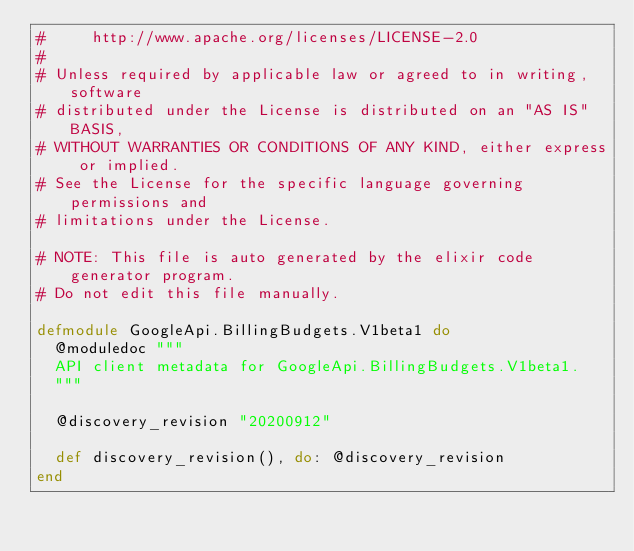<code> <loc_0><loc_0><loc_500><loc_500><_Elixir_>#     http://www.apache.org/licenses/LICENSE-2.0
#
# Unless required by applicable law or agreed to in writing, software
# distributed under the License is distributed on an "AS IS" BASIS,
# WITHOUT WARRANTIES OR CONDITIONS OF ANY KIND, either express or implied.
# See the License for the specific language governing permissions and
# limitations under the License.

# NOTE: This file is auto generated by the elixir code generator program.
# Do not edit this file manually.

defmodule GoogleApi.BillingBudgets.V1beta1 do
  @moduledoc """
  API client metadata for GoogleApi.BillingBudgets.V1beta1.
  """

  @discovery_revision "20200912"

  def discovery_revision(), do: @discovery_revision
end
</code> 